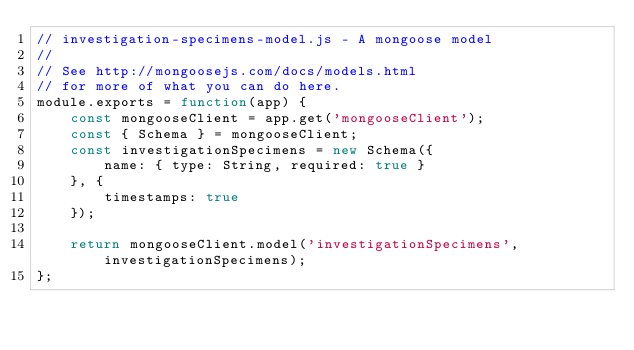<code> <loc_0><loc_0><loc_500><loc_500><_JavaScript_>// investigation-specimens-model.js - A mongoose model
//
// See http://mongoosejs.com/docs/models.html
// for more of what you can do here.
module.exports = function(app) {
    const mongooseClient = app.get('mongooseClient');
    const { Schema } = mongooseClient;
    const investigationSpecimens = new Schema({
        name: { type: String, required: true }
    }, {
        timestamps: true
    });

    return mongooseClient.model('investigationSpecimens', investigationSpecimens);
};</code> 